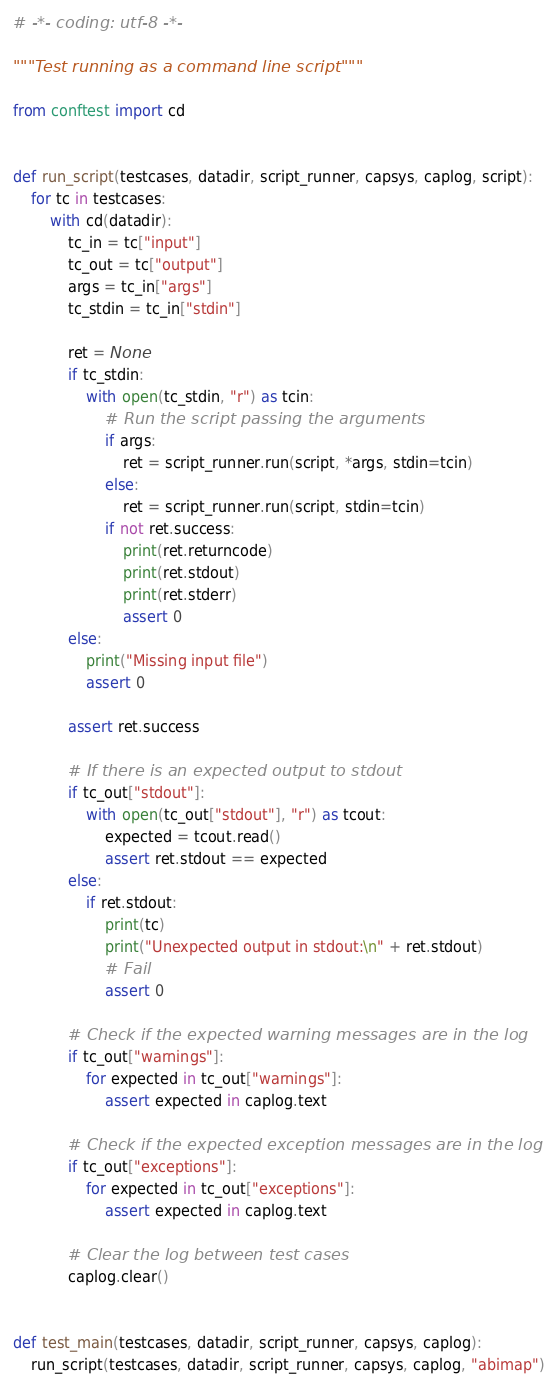<code> <loc_0><loc_0><loc_500><loc_500><_Python_># -*- coding: utf-8 -*-

"""Test running as a command line script"""

from conftest import cd


def run_script(testcases, datadir, script_runner, capsys, caplog, script):
    for tc in testcases:
        with cd(datadir):
            tc_in = tc["input"]
            tc_out = tc["output"]
            args = tc_in["args"]
            tc_stdin = tc_in["stdin"]

            ret = None
            if tc_stdin:
                with open(tc_stdin, "r") as tcin:
                    # Run the script passing the arguments
                    if args:
                        ret = script_runner.run(script, *args, stdin=tcin)
                    else:
                        ret = script_runner.run(script, stdin=tcin)
                    if not ret.success:
                        print(ret.returncode)
                        print(ret.stdout)
                        print(ret.stderr)
                        assert 0
            else:
                print("Missing input file")
                assert 0

            assert ret.success

            # If there is an expected output to stdout
            if tc_out["stdout"]:
                with open(tc_out["stdout"], "r") as tcout:
                    expected = tcout.read()
                    assert ret.stdout == expected
            else:
                if ret.stdout:
                    print(tc)
                    print("Unexpected output in stdout:\n" + ret.stdout)
                    # Fail
                    assert 0

            # Check if the expected warning messages are in the log
            if tc_out["warnings"]:
                for expected in tc_out["warnings"]:
                    assert expected in caplog.text

            # Check if the expected exception messages are in the log
            if tc_out["exceptions"]:
                for expected in tc_out["exceptions"]:
                    assert expected in caplog.text

            # Clear the log between test cases
            caplog.clear()


def test_main(testcases, datadir, script_runner, capsys, caplog):
    run_script(testcases, datadir, script_runner, capsys, caplog, "abimap")
</code> 